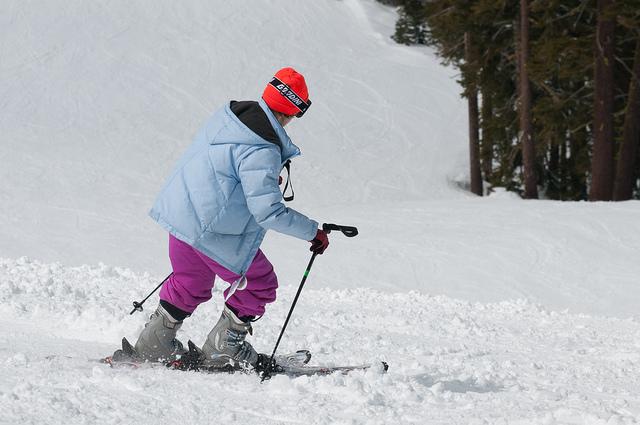What color is the inside of the hood?
Be succinct. Black. What is the man doing in the snow?
Be succinct. Skiing. What color are the man's pants?
Write a very short answer. Purple. 